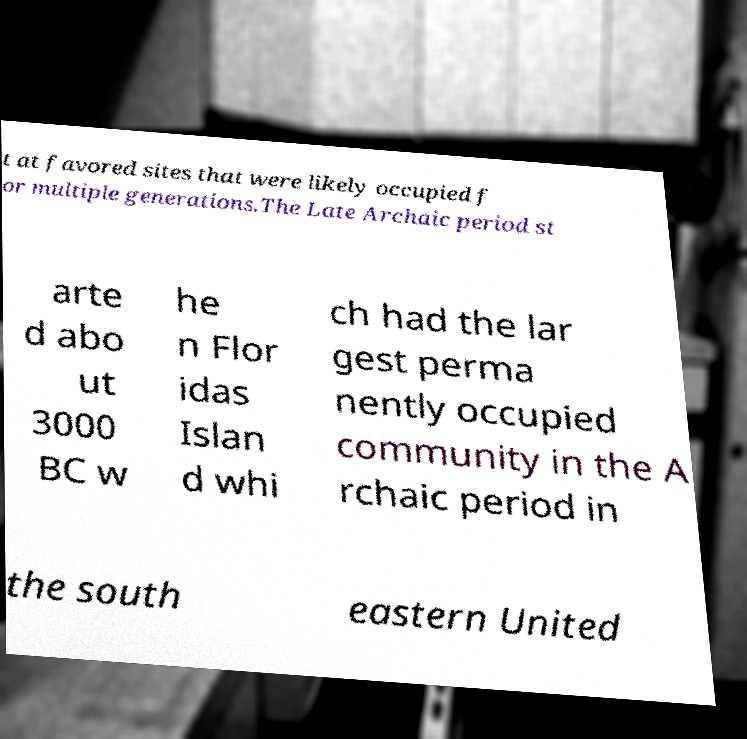For documentation purposes, I need the text within this image transcribed. Could you provide that? t at favored sites that were likely occupied f or multiple generations.The Late Archaic period st arte d abo ut 3000 BC w he n Flor idas Islan d whi ch had the lar gest perma nently occupied community in the A rchaic period in the south eastern United 